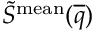Convert formula to latex. <formula><loc_0><loc_0><loc_500><loc_500>\widetilde { S } ^ { m e a n } ( \overline { q } )</formula> 